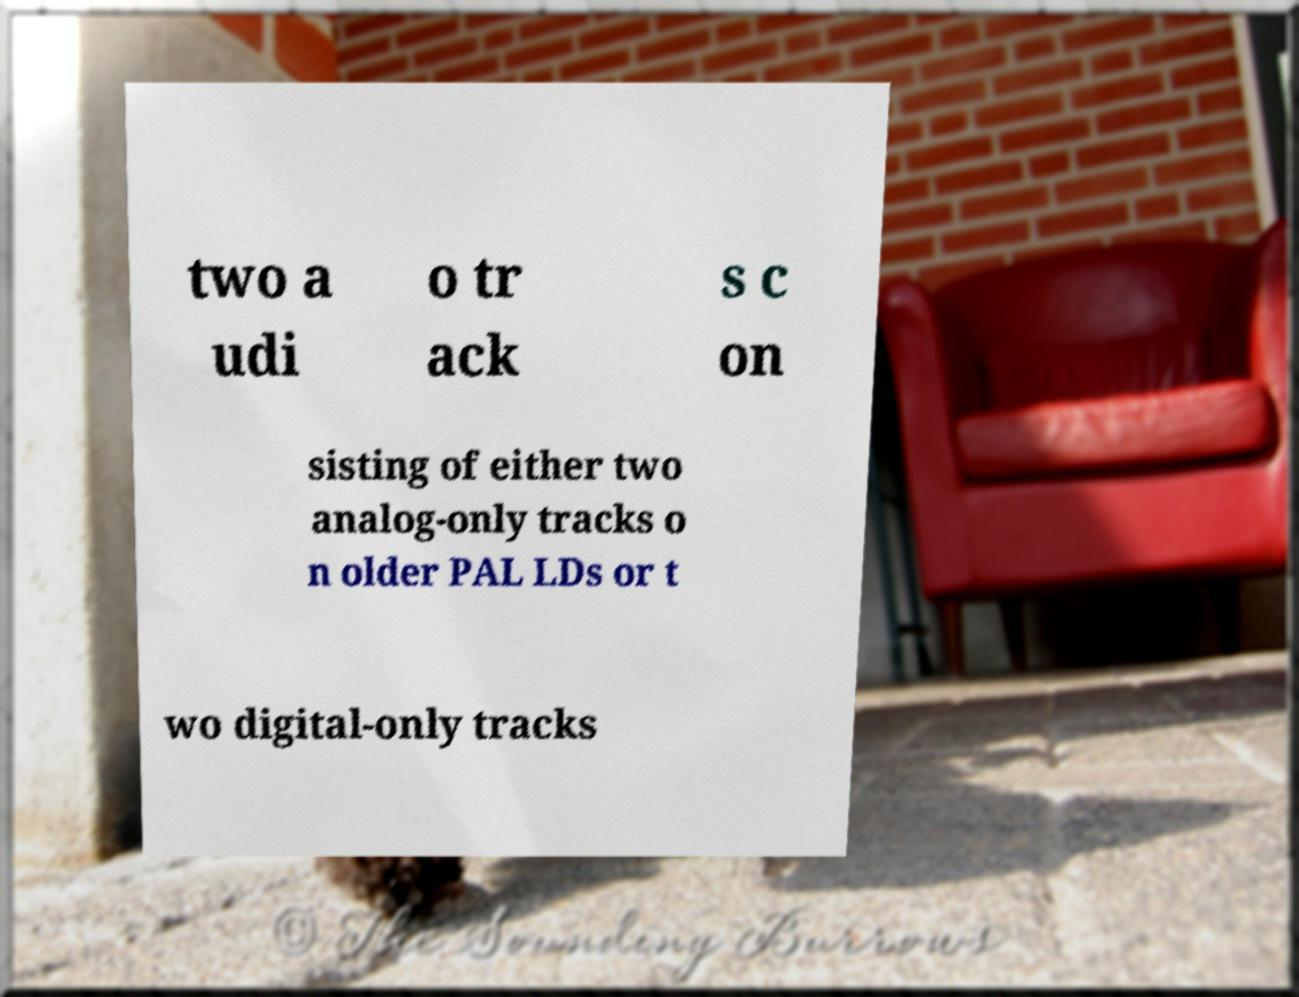There's text embedded in this image that I need extracted. Can you transcribe it verbatim? two a udi o tr ack s c on sisting of either two analog-only tracks o n older PAL LDs or t wo digital-only tracks 